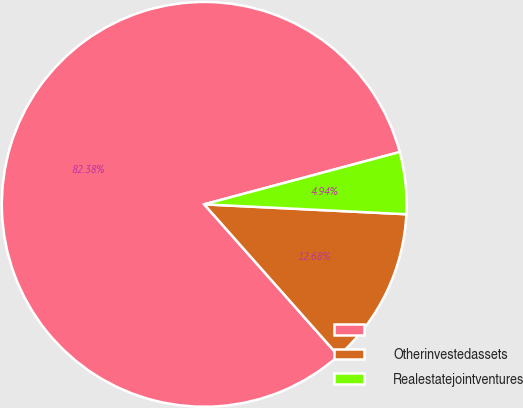<chart> <loc_0><loc_0><loc_500><loc_500><pie_chart><ecel><fcel>Otherinvestedassets<fcel>Realestatejointventures<nl><fcel>82.38%<fcel>12.68%<fcel>4.94%<nl></chart> 